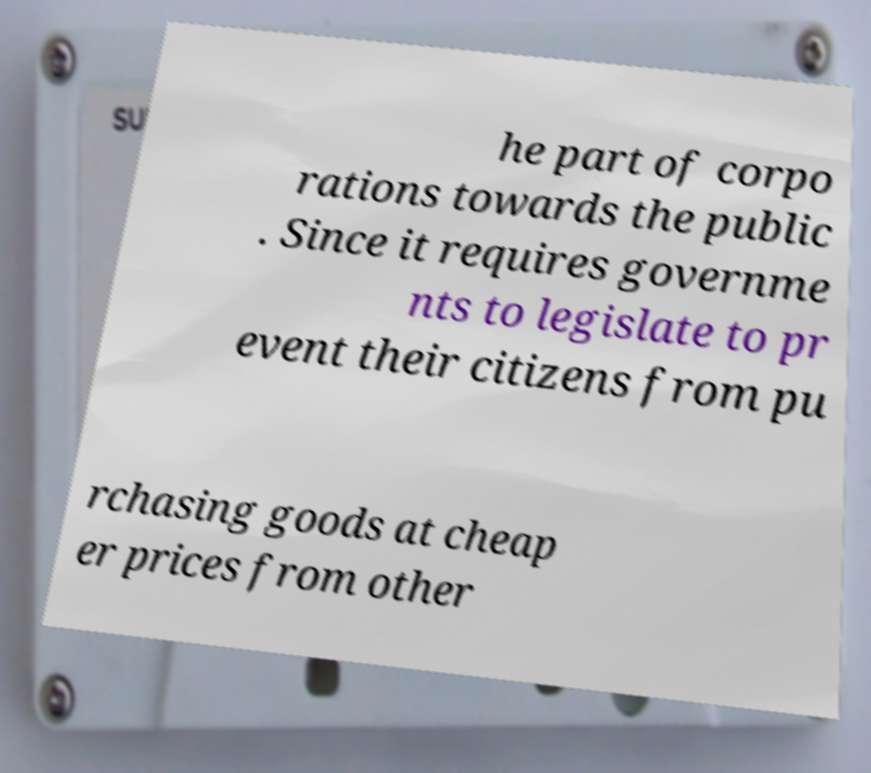Can you accurately transcribe the text from the provided image for me? he part of corpo rations towards the public . Since it requires governme nts to legislate to pr event their citizens from pu rchasing goods at cheap er prices from other 